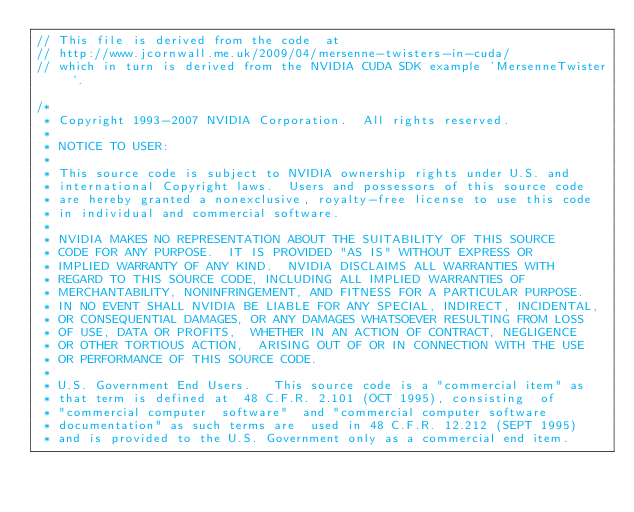Convert code to text. <code><loc_0><loc_0><loc_500><loc_500><_Cuda_>// This file is derived from the code  at 
// http://www.jcornwall.me.uk/2009/04/mersenne-twisters-in-cuda/
// which in turn is derived from the NVIDIA CUDA SDK example 'MersenneTwister'.

/*
 * Copyright 1993-2007 NVIDIA Corporation.  All rights reserved.
 *
 * NOTICE TO USER:
 *
 * This source code is subject to NVIDIA ownership rights under U.S. and
 * international Copyright laws.  Users and possessors of this source code
 * are hereby granted a nonexclusive, royalty-free license to use this code
 * in individual and commercial software.
 *
 * NVIDIA MAKES NO REPRESENTATION ABOUT THE SUITABILITY OF THIS SOURCE
 * CODE FOR ANY PURPOSE.  IT IS PROVIDED "AS IS" WITHOUT EXPRESS OR
 * IMPLIED WARRANTY OF ANY KIND.  NVIDIA DISCLAIMS ALL WARRANTIES WITH
 * REGARD TO THIS SOURCE CODE, INCLUDING ALL IMPLIED WARRANTIES OF
 * MERCHANTABILITY, NONINFRINGEMENT, AND FITNESS FOR A PARTICULAR PURPOSE.
 * IN NO EVENT SHALL NVIDIA BE LIABLE FOR ANY SPECIAL, INDIRECT, INCIDENTAL,
 * OR CONSEQUENTIAL DAMAGES, OR ANY DAMAGES WHATSOEVER RESULTING FROM LOSS
 * OF USE, DATA OR PROFITS,  WHETHER IN AN ACTION OF CONTRACT, NEGLIGENCE
 * OR OTHER TORTIOUS ACTION,  ARISING OUT OF OR IN CONNECTION WITH THE USE
 * OR PERFORMANCE OF THIS SOURCE CODE.
 *
 * U.S. Government End Users.   This source code is a "commercial item" as
 * that term is defined at  48 C.F.R. 2.101 (OCT 1995), consisting  of
 * "commercial computer  software"  and "commercial computer software
 * documentation" as such terms are  used in 48 C.F.R. 12.212 (SEPT 1995)
 * and is provided to the U.S. Government only as a commercial end item.</code> 